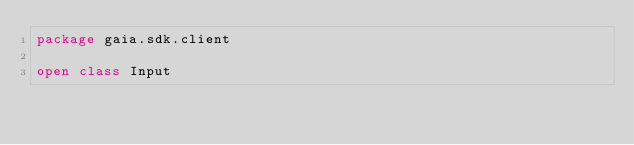<code> <loc_0><loc_0><loc_500><loc_500><_Kotlin_>package gaia.sdk.client

open class Input
</code> 